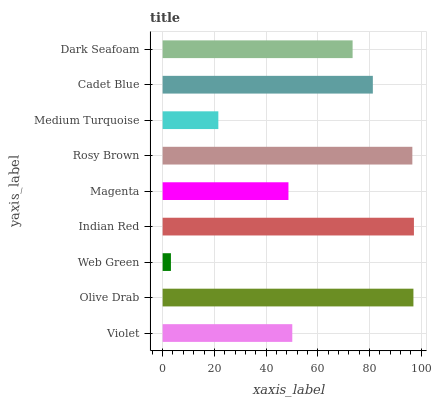Is Web Green the minimum?
Answer yes or no. Yes. Is Indian Red the maximum?
Answer yes or no. Yes. Is Olive Drab the minimum?
Answer yes or no. No. Is Olive Drab the maximum?
Answer yes or no. No. Is Olive Drab greater than Violet?
Answer yes or no. Yes. Is Violet less than Olive Drab?
Answer yes or no. Yes. Is Violet greater than Olive Drab?
Answer yes or no. No. Is Olive Drab less than Violet?
Answer yes or no. No. Is Dark Seafoam the high median?
Answer yes or no. Yes. Is Dark Seafoam the low median?
Answer yes or no. Yes. Is Web Green the high median?
Answer yes or no. No. Is Web Green the low median?
Answer yes or no. No. 